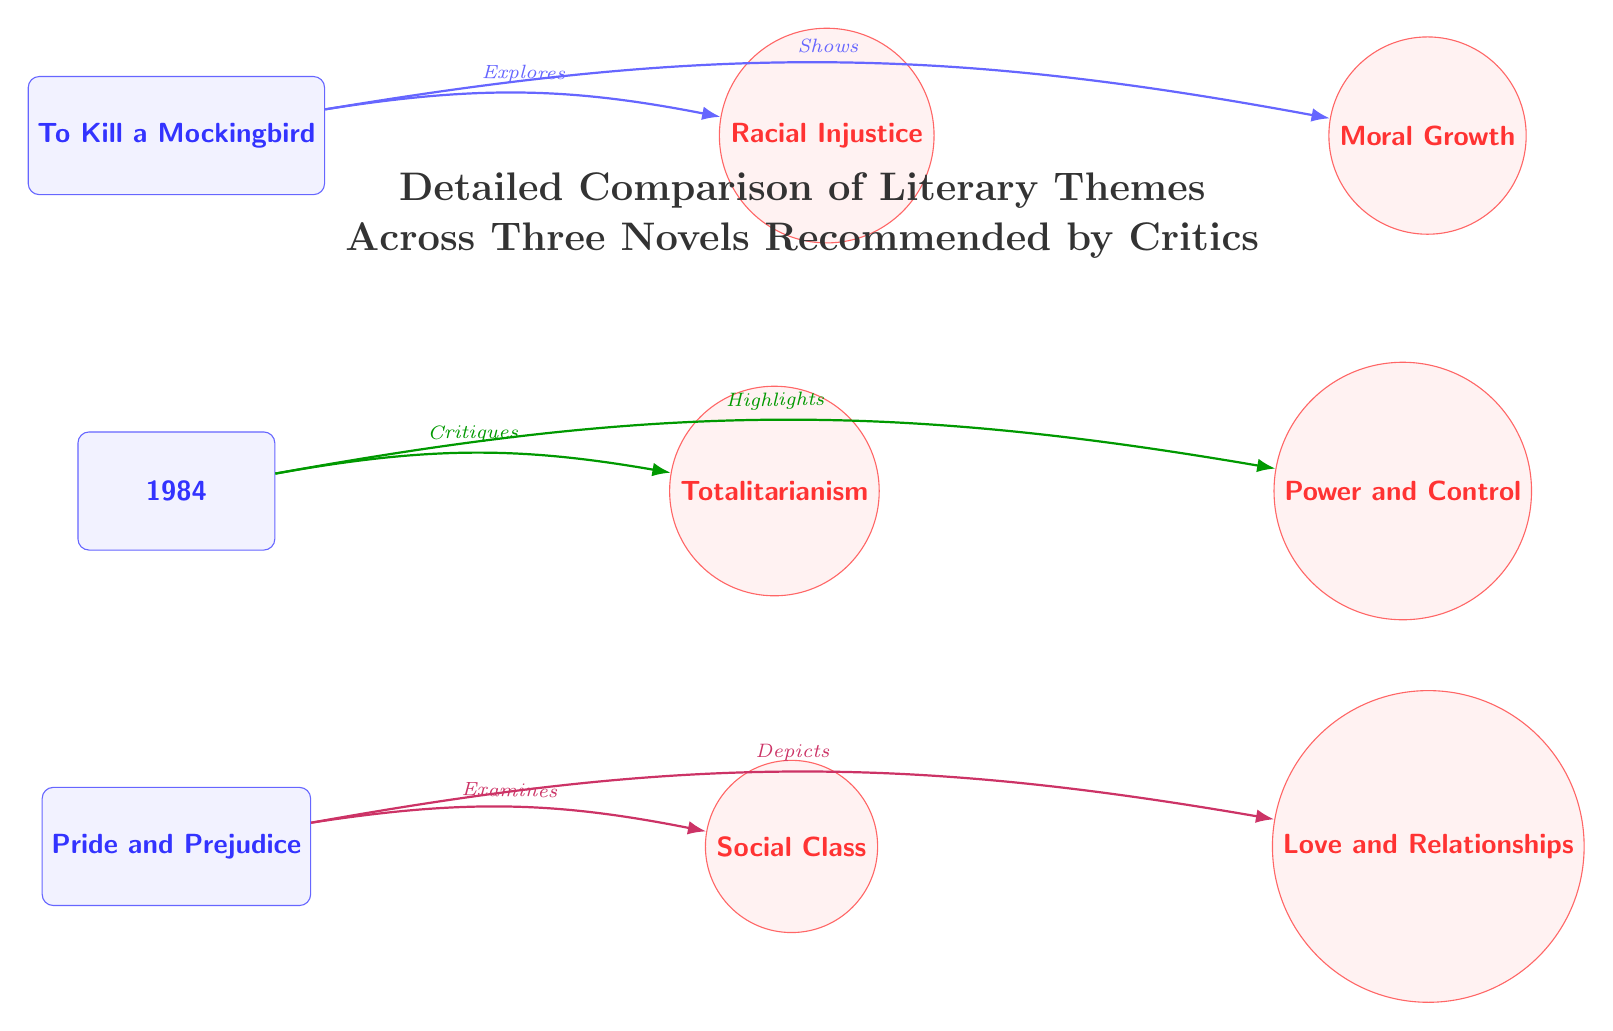What is the title of the diagram? The title is explicitly stated at the top of the diagram, which describes the purpose of the visuals presented: a comparison of themes in three novels.
Answer: Detailed Comparison of Literary Themes Across Three Novels Recommended by Critics How many novels are depicted in the diagram? By examining the diagram, there are three distinct novel nodes represented at the top portion.
Answer: 3 What theme is associated with "To Kill a Mockingbird"? Looking at the arrows leading from "To Kill a Mockingbird," we can identify that it explores "Racial Injustice" and shows "Moral Growth."
Answer: Racial Injustice Which novel critiques totalitarianism? By following the connection from the node labeled "1984," it is clear that this novel critiques the theme of "Totalitarianism."
Answer: 1984 What theme does "Pride and Prejudice" examine? Referring to the connections stemming from "Pride and Prejudice," it is indicated that the novel examines "Social Class."
Answer: Social Class Which novel shows the theme of love and relationships? The "Pride and Prejudice" node shows a connection leading to the theme "Love and Relationships," indicating this theme is depicted in that novel.
Answer: Pride and Prejudice What type of relationship does "1984" have with "Power and Control"? The relationship is established by the arrow labeled "Highlights," indicating that "1984" draws attention to the theme of "Power and Control."
Answer: Highlights How are the themes visually distinguished in the diagram? The themes in the diagram are represented by circular nodes, while the novels are shown as rectangular nodes, making it easy to differentiate between the two categories.
Answer: Circular and rectangular nodes What does the arrow from "To Kill a Mockingbird" to "Moral Growth" signify? The arrow labeled "Shows" indicates that "To Kill a Mockingbird" presents or illustrates the theme of "Moral Growth."
Answer: Shows 